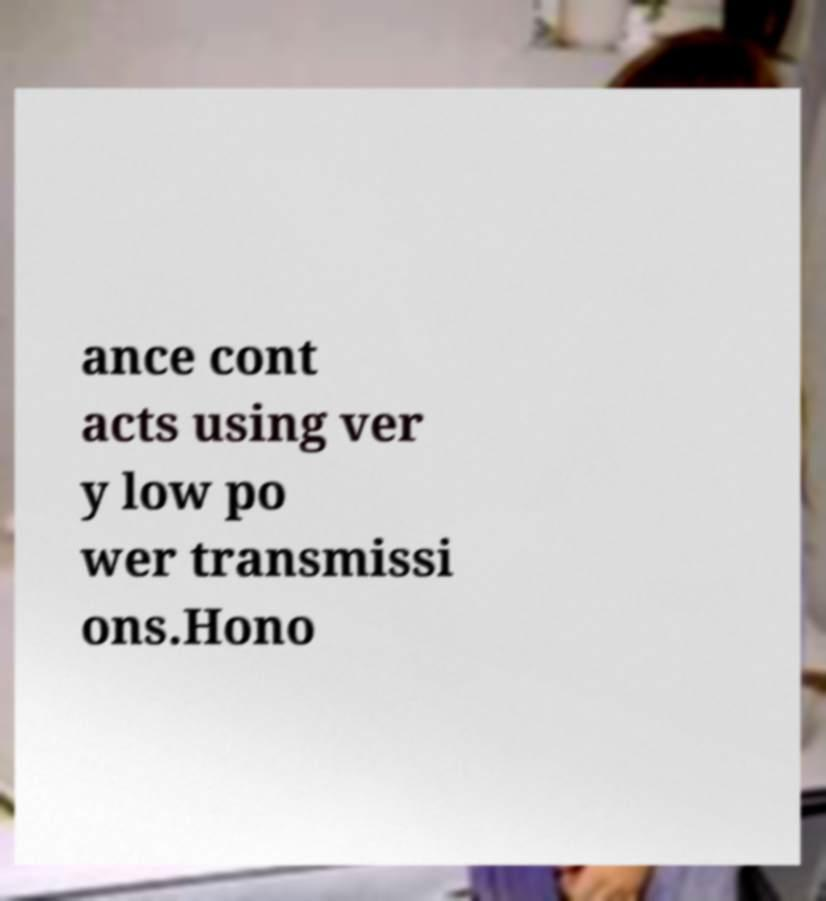There's text embedded in this image that I need extracted. Can you transcribe it verbatim? ance cont acts using ver y low po wer transmissi ons.Hono 